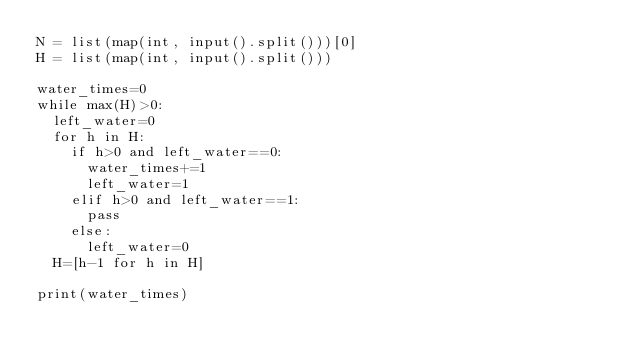Convert code to text. <code><loc_0><loc_0><loc_500><loc_500><_Python_>N = list(map(int, input().split()))[0]
H = list(map(int, input().split()))

water_times=0
while max(H)>0:
  left_water=0
  for h in H:
    if h>0 and left_water==0:
      water_times+=1
      left_water=1
    elif h>0 and left_water==1:
      pass
    else:
      left_water=0
  H=[h-1 for h in H]

print(water_times)</code> 